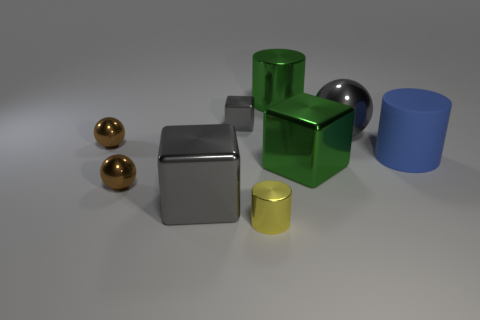Subtract all balls. How many objects are left? 6 Subtract all small yellow metal things. Subtract all large green cylinders. How many objects are left? 7 Add 2 tiny brown objects. How many tiny brown objects are left? 4 Add 5 big red matte blocks. How many big red matte blocks exist? 5 Subtract 0 cyan balls. How many objects are left? 9 